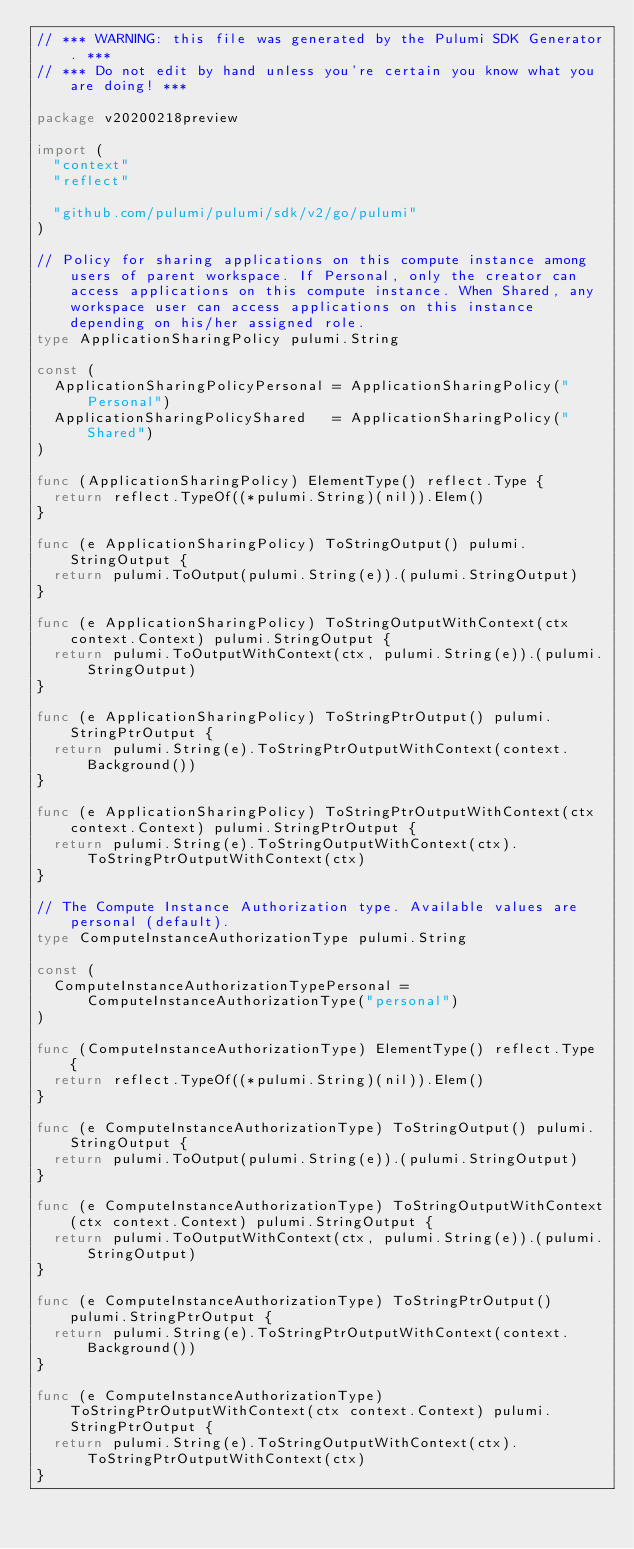Convert code to text. <code><loc_0><loc_0><loc_500><loc_500><_Go_>// *** WARNING: this file was generated by the Pulumi SDK Generator. ***
// *** Do not edit by hand unless you're certain you know what you are doing! ***

package v20200218preview

import (
	"context"
	"reflect"

	"github.com/pulumi/pulumi/sdk/v2/go/pulumi"
)

// Policy for sharing applications on this compute instance among users of parent workspace. If Personal, only the creator can access applications on this compute instance. When Shared, any workspace user can access applications on this instance depending on his/her assigned role.
type ApplicationSharingPolicy pulumi.String

const (
	ApplicationSharingPolicyPersonal = ApplicationSharingPolicy("Personal")
	ApplicationSharingPolicyShared   = ApplicationSharingPolicy("Shared")
)

func (ApplicationSharingPolicy) ElementType() reflect.Type {
	return reflect.TypeOf((*pulumi.String)(nil)).Elem()
}

func (e ApplicationSharingPolicy) ToStringOutput() pulumi.StringOutput {
	return pulumi.ToOutput(pulumi.String(e)).(pulumi.StringOutput)
}

func (e ApplicationSharingPolicy) ToStringOutputWithContext(ctx context.Context) pulumi.StringOutput {
	return pulumi.ToOutputWithContext(ctx, pulumi.String(e)).(pulumi.StringOutput)
}

func (e ApplicationSharingPolicy) ToStringPtrOutput() pulumi.StringPtrOutput {
	return pulumi.String(e).ToStringPtrOutputWithContext(context.Background())
}

func (e ApplicationSharingPolicy) ToStringPtrOutputWithContext(ctx context.Context) pulumi.StringPtrOutput {
	return pulumi.String(e).ToStringOutputWithContext(ctx).ToStringPtrOutputWithContext(ctx)
}

// The Compute Instance Authorization type. Available values are personal (default).
type ComputeInstanceAuthorizationType pulumi.String

const (
	ComputeInstanceAuthorizationTypePersonal = ComputeInstanceAuthorizationType("personal")
)

func (ComputeInstanceAuthorizationType) ElementType() reflect.Type {
	return reflect.TypeOf((*pulumi.String)(nil)).Elem()
}

func (e ComputeInstanceAuthorizationType) ToStringOutput() pulumi.StringOutput {
	return pulumi.ToOutput(pulumi.String(e)).(pulumi.StringOutput)
}

func (e ComputeInstanceAuthorizationType) ToStringOutputWithContext(ctx context.Context) pulumi.StringOutput {
	return pulumi.ToOutputWithContext(ctx, pulumi.String(e)).(pulumi.StringOutput)
}

func (e ComputeInstanceAuthorizationType) ToStringPtrOutput() pulumi.StringPtrOutput {
	return pulumi.String(e).ToStringPtrOutputWithContext(context.Background())
}

func (e ComputeInstanceAuthorizationType) ToStringPtrOutputWithContext(ctx context.Context) pulumi.StringPtrOutput {
	return pulumi.String(e).ToStringOutputWithContext(ctx).ToStringPtrOutputWithContext(ctx)
}
</code> 